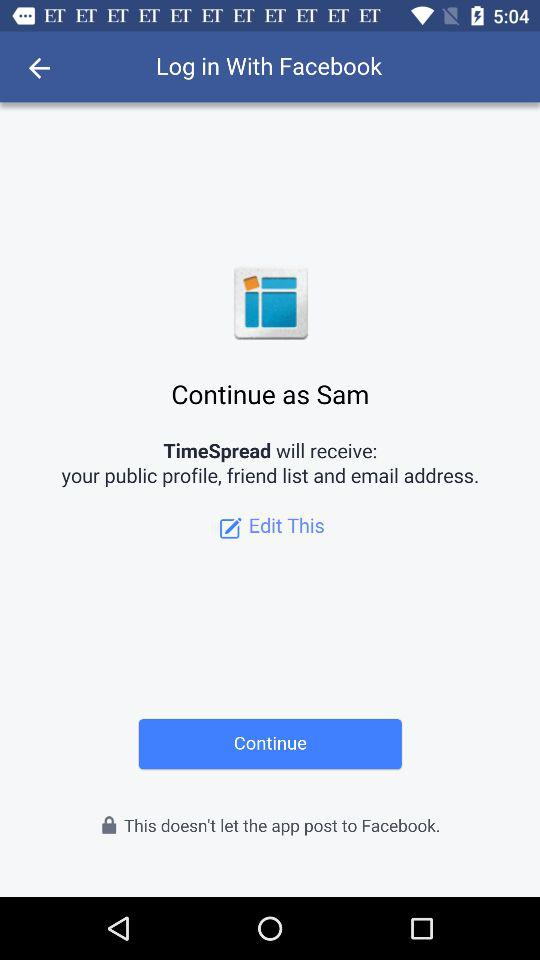Which option is selected?
When the provided information is insufficient, respond with <no answer>. <no answer> 